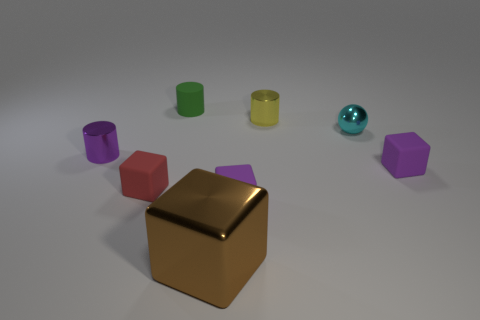Is there any other thing that has the same shape as the small cyan metal object?
Provide a short and direct response. No. There is a small sphere that is the same material as the big thing; what is its color?
Your answer should be very brief. Cyan. Are there any rubber things in front of the metallic object left of the small green rubber thing?
Your answer should be very brief. Yes. There is a shiny ball that is the same size as the red rubber block; what color is it?
Keep it short and to the point. Cyan. What number of things are either large brown matte cylinders or green cylinders?
Your response must be concise. 1. What is the size of the metallic object that is in front of the tiny purple matte thing that is behind the small purple matte cube that is in front of the small red matte block?
Your response must be concise. Large. How many small metallic things have the same color as the tiny rubber cylinder?
Your answer should be compact. 0. What number of other large gray blocks have the same material as the large cube?
Make the answer very short. 0. What number of things are tiny gray objects or tiny shiny objects that are right of the tiny yellow thing?
Provide a short and direct response. 1. There is a metal thing in front of the small metallic cylinder that is in front of the cylinder that is right of the green cylinder; what is its color?
Offer a terse response. Brown. 